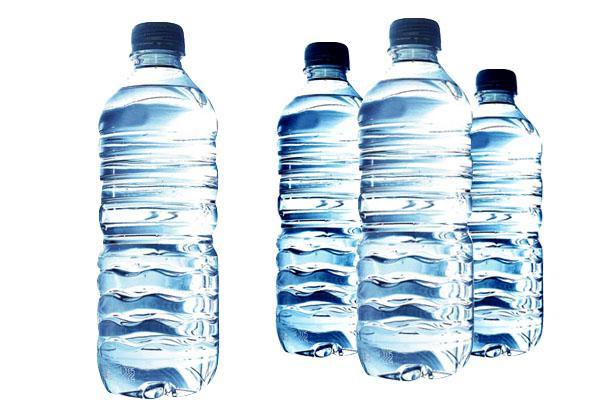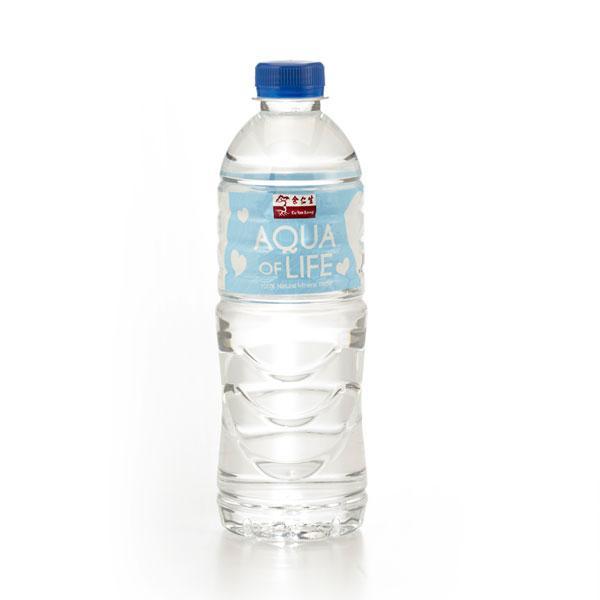The first image is the image on the left, the second image is the image on the right. For the images displayed, is the sentence "Each image contains exactly one water bottle with a blue lid." factually correct? Answer yes or no. No. The first image is the image on the left, the second image is the image on the right. Analyze the images presented: Is the assertion "At least one of the bottles doesn't have a lable." valid? Answer yes or no. Yes. 